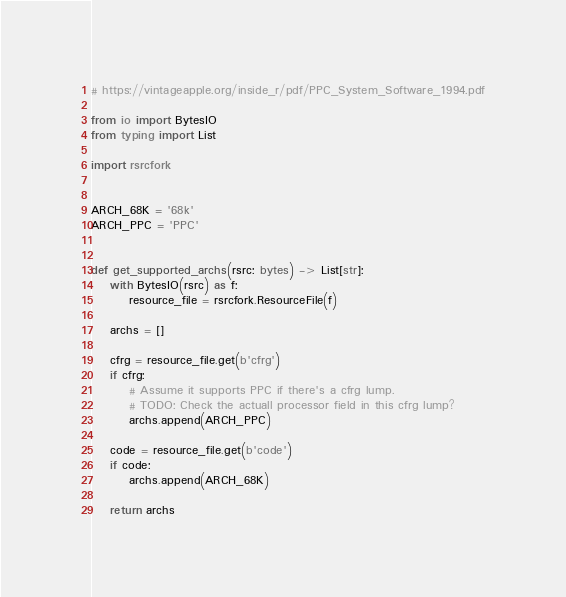Convert code to text. <code><loc_0><loc_0><loc_500><loc_500><_Python_># https://vintageapple.org/inside_r/pdf/PPC_System_Software_1994.pdf

from io import BytesIO
from typing import List

import rsrcfork


ARCH_68K = '68k'
ARCH_PPC = 'PPC'


def get_supported_archs(rsrc: bytes) -> List[str]:
    with BytesIO(rsrc) as f:
        resource_file = rsrcfork.ResourceFile(f)

    archs = []

    cfrg = resource_file.get(b'cfrg')
    if cfrg:
        # Assume it supports PPC if there's a cfrg lump.
        # TODO: Check the actuall processor field in this cfrg lump?
        archs.append(ARCH_PPC)

    code = resource_file.get(b'code')
    if code:
        archs.append(ARCH_68K)

    return archs

</code> 